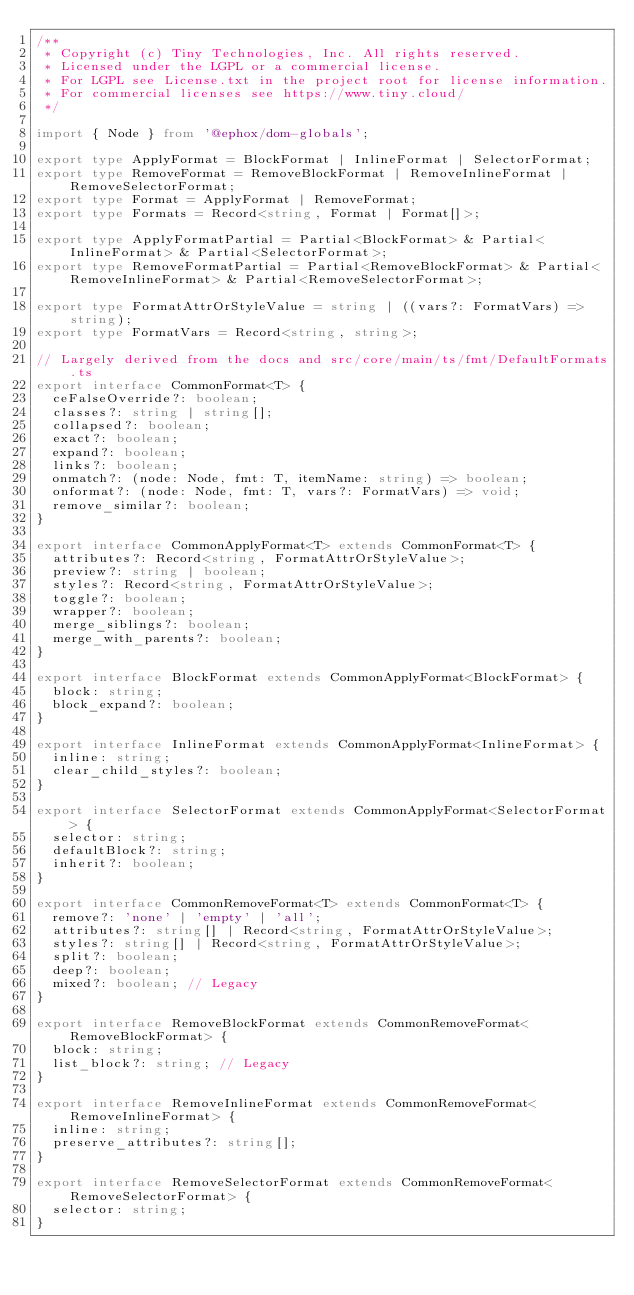Convert code to text. <code><loc_0><loc_0><loc_500><loc_500><_TypeScript_>/**
 * Copyright (c) Tiny Technologies, Inc. All rights reserved.
 * Licensed under the LGPL or a commercial license.
 * For LGPL see License.txt in the project root for license information.
 * For commercial licenses see https://www.tiny.cloud/
 */

import { Node } from '@ephox/dom-globals';

export type ApplyFormat = BlockFormat | InlineFormat | SelectorFormat;
export type RemoveFormat = RemoveBlockFormat | RemoveInlineFormat | RemoveSelectorFormat;
export type Format = ApplyFormat | RemoveFormat;
export type Formats = Record<string, Format | Format[]>;

export type ApplyFormatPartial = Partial<BlockFormat> & Partial<InlineFormat> & Partial<SelectorFormat>;
export type RemoveFormatPartial = Partial<RemoveBlockFormat> & Partial<RemoveInlineFormat> & Partial<RemoveSelectorFormat>;

export type FormatAttrOrStyleValue = string | ((vars?: FormatVars) => string);
export type FormatVars = Record<string, string>;

// Largely derived from the docs and src/core/main/ts/fmt/DefaultFormats.ts
export interface CommonFormat<T> {
  ceFalseOverride?: boolean;
  classes?: string | string[];
  collapsed?: boolean;
  exact?: boolean;
  expand?: boolean;
  links?: boolean;
  onmatch?: (node: Node, fmt: T, itemName: string) => boolean;
  onformat?: (node: Node, fmt: T, vars?: FormatVars) => void;
  remove_similar?: boolean;
}

export interface CommonApplyFormat<T> extends CommonFormat<T> {
  attributes?: Record<string, FormatAttrOrStyleValue>;
  preview?: string | boolean;
  styles?: Record<string, FormatAttrOrStyleValue>;
  toggle?: boolean;
  wrapper?: boolean;
  merge_siblings?: boolean;
  merge_with_parents?: boolean;
}

export interface BlockFormat extends CommonApplyFormat<BlockFormat> {
  block: string;
  block_expand?: boolean;
}

export interface InlineFormat extends CommonApplyFormat<InlineFormat> {
  inline: string;
  clear_child_styles?: boolean;
}

export interface SelectorFormat extends CommonApplyFormat<SelectorFormat> {
  selector: string;
  defaultBlock?: string;
  inherit?: boolean;
}

export interface CommonRemoveFormat<T> extends CommonFormat<T> {
  remove?: 'none' | 'empty' | 'all';
  attributes?: string[] | Record<string, FormatAttrOrStyleValue>;
  styles?: string[] | Record<string, FormatAttrOrStyleValue>;
  split?: boolean;
  deep?: boolean;
  mixed?: boolean; // Legacy
}

export interface RemoveBlockFormat extends CommonRemoveFormat<RemoveBlockFormat> {
  block: string;
  list_block?: string; // Legacy
}

export interface RemoveInlineFormat extends CommonRemoveFormat<RemoveInlineFormat> {
  inline: string;
  preserve_attributes?: string[];
}

export interface RemoveSelectorFormat extends CommonRemoveFormat<RemoveSelectorFormat> {
  selector: string;
}
</code> 